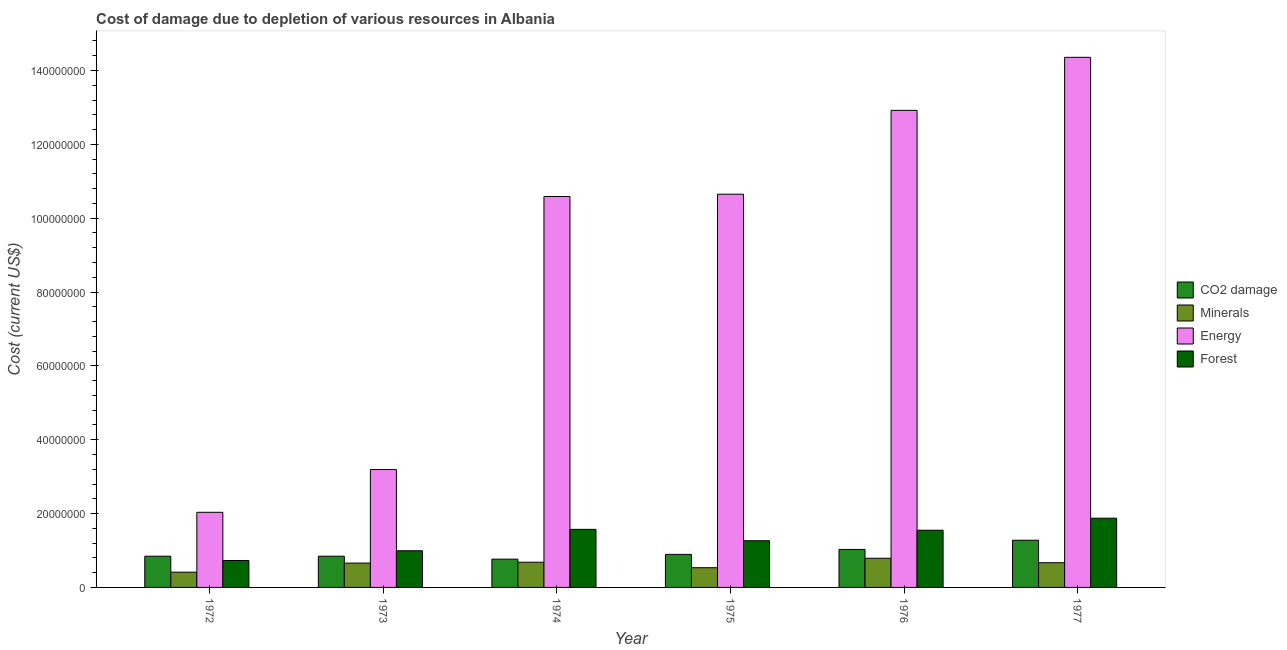How many different coloured bars are there?
Keep it short and to the point. 4. How many groups of bars are there?
Give a very brief answer. 6. Are the number of bars on each tick of the X-axis equal?
Give a very brief answer. Yes. How many bars are there on the 5th tick from the left?
Ensure brevity in your answer.  4. How many bars are there on the 6th tick from the right?
Give a very brief answer. 4. What is the cost of damage due to depletion of forests in 1977?
Offer a terse response. 1.88e+07. Across all years, what is the maximum cost of damage due to depletion of energy?
Offer a very short reply. 1.44e+08. Across all years, what is the minimum cost of damage due to depletion of energy?
Ensure brevity in your answer.  2.03e+07. In which year was the cost of damage due to depletion of minerals maximum?
Provide a short and direct response. 1976. In which year was the cost of damage due to depletion of coal minimum?
Keep it short and to the point. 1974. What is the total cost of damage due to depletion of forests in the graph?
Keep it short and to the point. 7.99e+07. What is the difference between the cost of damage due to depletion of coal in 1972 and that in 1977?
Provide a short and direct response. -4.32e+06. What is the difference between the cost of damage due to depletion of coal in 1974 and the cost of damage due to depletion of energy in 1972?
Your answer should be very brief. -7.97e+05. What is the average cost of damage due to depletion of coal per year?
Make the answer very short. 9.43e+06. In how many years, is the cost of damage due to depletion of coal greater than 24000000 US$?
Your response must be concise. 0. What is the ratio of the cost of damage due to depletion of coal in 1974 to that in 1977?
Your response must be concise. 0.6. Is the difference between the cost of damage due to depletion of minerals in 1973 and 1977 greater than the difference between the cost of damage due to depletion of energy in 1973 and 1977?
Your answer should be very brief. No. What is the difference between the highest and the second highest cost of damage due to depletion of forests?
Offer a very short reply. 3.02e+06. What is the difference between the highest and the lowest cost of damage due to depletion of minerals?
Offer a very short reply. 3.77e+06. Is the sum of the cost of damage due to depletion of minerals in 1974 and 1976 greater than the maximum cost of damage due to depletion of energy across all years?
Make the answer very short. Yes. What does the 4th bar from the left in 1972 represents?
Your response must be concise. Forest. What does the 3rd bar from the right in 1977 represents?
Provide a succinct answer. Minerals. Is it the case that in every year, the sum of the cost of damage due to depletion of coal and cost of damage due to depletion of minerals is greater than the cost of damage due to depletion of energy?
Offer a terse response. No. Are all the bars in the graph horizontal?
Your answer should be compact. No. How many years are there in the graph?
Give a very brief answer. 6. Are the values on the major ticks of Y-axis written in scientific E-notation?
Offer a very short reply. No. Where does the legend appear in the graph?
Keep it short and to the point. Center right. What is the title of the graph?
Give a very brief answer. Cost of damage due to depletion of various resources in Albania . What is the label or title of the Y-axis?
Your answer should be compact. Cost (current US$). What is the Cost (current US$) in CO2 damage in 1972?
Your answer should be compact. 8.45e+06. What is the Cost (current US$) of Minerals in 1972?
Provide a succinct answer. 4.13e+06. What is the Cost (current US$) in Energy in 1972?
Give a very brief answer. 2.03e+07. What is the Cost (current US$) of Forest in 1972?
Make the answer very short. 7.29e+06. What is the Cost (current US$) in CO2 damage in 1973?
Provide a short and direct response. 8.46e+06. What is the Cost (current US$) in Minerals in 1973?
Keep it short and to the point. 6.59e+06. What is the Cost (current US$) of Energy in 1973?
Ensure brevity in your answer.  3.19e+07. What is the Cost (current US$) in Forest in 1973?
Offer a very short reply. 9.93e+06. What is the Cost (current US$) in CO2 damage in 1974?
Provide a short and direct response. 7.66e+06. What is the Cost (current US$) of Minerals in 1974?
Keep it short and to the point. 6.83e+06. What is the Cost (current US$) of Energy in 1974?
Offer a terse response. 1.06e+08. What is the Cost (current US$) of Forest in 1974?
Give a very brief answer. 1.57e+07. What is the Cost (current US$) of CO2 damage in 1975?
Provide a succinct answer. 8.95e+06. What is the Cost (current US$) of Minerals in 1975?
Offer a terse response. 5.34e+06. What is the Cost (current US$) of Energy in 1975?
Provide a short and direct response. 1.06e+08. What is the Cost (current US$) of Forest in 1975?
Offer a terse response. 1.26e+07. What is the Cost (current US$) in CO2 damage in 1976?
Provide a succinct answer. 1.03e+07. What is the Cost (current US$) of Minerals in 1976?
Provide a short and direct response. 7.90e+06. What is the Cost (current US$) in Energy in 1976?
Offer a very short reply. 1.29e+08. What is the Cost (current US$) of Forest in 1976?
Make the answer very short. 1.55e+07. What is the Cost (current US$) of CO2 damage in 1977?
Keep it short and to the point. 1.28e+07. What is the Cost (current US$) in Minerals in 1977?
Your response must be concise. 6.69e+06. What is the Cost (current US$) of Energy in 1977?
Ensure brevity in your answer.  1.44e+08. What is the Cost (current US$) in Forest in 1977?
Keep it short and to the point. 1.88e+07. Across all years, what is the maximum Cost (current US$) of CO2 damage?
Ensure brevity in your answer.  1.28e+07. Across all years, what is the maximum Cost (current US$) in Minerals?
Offer a very short reply. 7.90e+06. Across all years, what is the maximum Cost (current US$) in Energy?
Give a very brief answer. 1.44e+08. Across all years, what is the maximum Cost (current US$) of Forest?
Your answer should be compact. 1.88e+07. Across all years, what is the minimum Cost (current US$) in CO2 damage?
Your answer should be very brief. 7.66e+06. Across all years, what is the minimum Cost (current US$) in Minerals?
Provide a short and direct response. 4.13e+06. Across all years, what is the minimum Cost (current US$) of Energy?
Provide a succinct answer. 2.03e+07. Across all years, what is the minimum Cost (current US$) of Forest?
Offer a terse response. 7.29e+06. What is the total Cost (current US$) of CO2 damage in the graph?
Your answer should be compact. 5.66e+07. What is the total Cost (current US$) in Minerals in the graph?
Provide a succinct answer. 3.75e+07. What is the total Cost (current US$) in Energy in the graph?
Provide a succinct answer. 5.37e+08. What is the total Cost (current US$) of Forest in the graph?
Provide a short and direct response. 7.99e+07. What is the difference between the Cost (current US$) of CO2 damage in 1972 and that in 1973?
Your response must be concise. -2181.69. What is the difference between the Cost (current US$) of Minerals in 1972 and that in 1973?
Offer a very short reply. -2.46e+06. What is the difference between the Cost (current US$) of Energy in 1972 and that in 1973?
Provide a short and direct response. -1.16e+07. What is the difference between the Cost (current US$) of Forest in 1972 and that in 1973?
Offer a very short reply. -2.64e+06. What is the difference between the Cost (current US$) in CO2 damage in 1972 and that in 1974?
Ensure brevity in your answer.  7.97e+05. What is the difference between the Cost (current US$) in Minerals in 1972 and that in 1974?
Offer a very short reply. -2.70e+06. What is the difference between the Cost (current US$) in Energy in 1972 and that in 1974?
Provide a short and direct response. -8.55e+07. What is the difference between the Cost (current US$) in Forest in 1972 and that in 1974?
Give a very brief answer. -8.43e+06. What is the difference between the Cost (current US$) in CO2 damage in 1972 and that in 1975?
Your answer should be very brief. -4.96e+05. What is the difference between the Cost (current US$) in Minerals in 1972 and that in 1975?
Give a very brief answer. -1.21e+06. What is the difference between the Cost (current US$) of Energy in 1972 and that in 1975?
Make the answer very short. -8.61e+07. What is the difference between the Cost (current US$) of Forest in 1972 and that in 1975?
Offer a terse response. -5.35e+06. What is the difference between the Cost (current US$) of CO2 damage in 1972 and that in 1976?
Provide a succinct answer. -1.84e+06. What is the difference between the Cost (current US$) of Minerals in 1972 and that in 1976?
Provide a short and direct response. -3.77e+06. What is the difference between the Cost (current US$) of Energy in 1972 and that in 1976?
Your response must be concise. -1.09e+08. What is the difference between the Cost (current US$) in Forest in 1972 and that in 1976?
Your answer should be compact. -8.20e+06. What is the difference between the Cost (current US$) in CO2 damage in 1972 and that in 1977?
Your answer should be compact. -4.32e+06. What is the difference between the Cost (current US$) in Minerals in 1972 and that in 1977?
Offer a very short reply. -2.56e+06. What is the difference between the Cost (current US$) in Energy in 1972 and that in 1977?
Offer a very short reply. -1.23e+08. What is the difference between the Cost (current US$) of Forest in 1972 and that in 1977?
Give a very brief answer. -1.15e+07. What is the difference between the Cost (current US$) in CO2 damage in 1973 and that in 1974?
Offer a very short reply. 7.99e+05. What is the difference between the Cost (current US$) of Minerals in 1973 and that in 1974?
Offer a very short reply. -2.35e+05. What is the difference between the Cost (current US$) in Energy in 1973 and that in 1974?
Provide a short and direct response. -7.39e+07. What is the difference between the Cost (current US$) in Forest in 1973 and that in 1974?
Give a very brief answer. -5.80e+06. What is the difference between the Cost (current US$) of CO2 damage in 1973 and that in 1975?
Offer a terse response. -4.94e+05. What is the difference between the Cost (current US$) in Minerals in 1973 and that in 1975?
Give a very brief answer. 1.25e+06. What is the difference between the Cost (current US$) of Energy in 1973 and that in 1975?
Provide a short and direct response. -7.46e+07. What is the difference between the Cost (current US$) in Forest in 1973 and that in 1975?
Provide a short and direct response. -2.72e+06. What is the difference between the Cost (current US$) of CO2 damage in 1973 and that in 1976?
Ensure brevity in your answer.  -1.84e+06. What is the difference between the Cost (current US$) of Minerals in 1973 and that in 1976?
Offer a terse response. -1.30e+06. What is the difference between the Cost (current US$) in Energy in 1973 and that in 1976?
Keep it short and to the point. -9.73e+07. What is the difference between the Cost (current US$) of Forest in 1973 and that in 1976?
Ensure brevity in your answer.  -5.56e+06. What is the difference between the Cost (current US$) of CO2 damage in 1973 and that in 1977?
Provide a short and direct response. -4.32e+06. What is the difference between the Cost (current US$) of Minerals in 1973 and that in 1977?
Your answer should be very brief. -1.01e+05. What is the difference between the Cost (current US$) of Energy in 1973 and that in 1977?
Offer a terse response. -1.12e+08. What is the difference between the Cost (current US$) of Forest in 1973 and that in 1977?
Your response must be concise. -8.82e+06. What is the difference between the Cost (current US$) of CO2 damage in 1974 and that in 1975?
Your answer should be very brief. -1.29e+06. What is the difference between the Cost (current US$) of Minerals in 1974 and that in 1975?
Ensure brevity in your answer.  1.49e+06. What is the difference between the Cost (current US$) in Energy in 1974 and that in 1975?
Offer a very short reply. -6.23e+05. What is the difference between the Cost (current US$) in Forest in 1974 and that in 1975?
Provide a succinct answer. 3.08e+06. What is the difference between the Cost (current US$) in CO2 damage in 1974 and that in 1976?
Offer a very short reply. -2.63e+06. What is the difference between the Cost (current US$) of Minerals in 1974 and that in 1976?
Your answer should be very brief. -1.07e+06. What is the difference between the Cost (current US$) in Energy in 1974 and that in 1976?
Make the answer very short. -2.33e+07. What is the difference between the Cost (current US$) of Forest in 1974 and that in 1976?
Provide a succinct answer. 2.37e+05. What is the difference between the Cost (current US$) of CO2 damage in 1974 and that in 1977?
Keep it short and to the point. -5.12e+06. What is the difference between the Cost (current US$) of Minerals in 1974 and that in 1977?
Make the answer very short. 1.34e+05. What is the difference between the Cost (current US$) in Energy in 1974 and that in 1977?
Your response must be concise. -3.77e+07. What is the difference between the Cost (current US$) of Forest in 1974 and that in 1977?
Your response must be concise. -3.02e+06. What is the difference between the Cost (current US$) in CO2 damage in 1975 and that in 1976?
Your answer should be very brief. -1.34e+06. What is the difference between the Cost (current US$) in Minerals in 1975 and that in 1976?
Provide a succinct answer. -2.56e+06. What is the difference between the Cost (current US$) of Energy in 1975 and that in 1976?
Make the answer very short. -2.27e+07. What is the difference between the Cost (current US$) of Forest in 1975 and that in 1976?
Your answer should be very brief. -2.84e+06. What is the difference between the Cost (current US$) of CO2 damage in 1975 and that in 1977?
Give a very brief answer. -3.83e+06. What is the difference between the Cost (current US$) of Minerals in 1975 and that in 1977?
Offer a very short reply. -1.36e+06. What is the difference between the Cost (current US$) of Energy in 1975 and that in 1977?
Your answer should be very brief. -3.71e+07. What is the difference between the Cost (current US$) of Forest in 1975 and that in 1977?
Your response must be concise. -6.10e+06. What is the difference between the Cost (current US$) in CO2 damage in 1976 and that in 1977?
Keep it short and to the point. -2.49e+06. What is the difference between the Cost (current US$) of Minerals in 1976 and that in 1977?
Offer a very short reply. 1.20e+06. What is the difference between the Cost (current US$) of Energy in 1976 and that in 1977?
Offer a very short reply. -1.44e+07. What is the difference between the Cost (current US$) in Forest in 1976 and that in 1977?
Offer a very short reply. -3.26e+06. What is the difference between the Cost (current US$) in CO2 damage in 1972 and the Cost (current US$) in Minerals in 1973?
Provide a succinct answer. 1.86e+06. What is the difference between the Cost (current US$) in CO2 damage in 1972 and the Cost (current US$) in Energy in 1973?
Make the answer very short. -2.35e+07. What is the difference between the Cost (current US$) of CO2 damage in 1972 and the Cost (current US$) of Forest in 1973?
Provide a succinct answer. -1.48e+06. What is the difference between the Cost (current US$) of Minerals in 1972 and the Cost (current US$) of Energy in 1973?
Your response must be concise. -2.78e+07. What is the difference between the Cost (current US$) in Minerals in 1972 and the Cost (current US$) in Forest in 1973?
Offer a very short reply. -5.80e+06. What is the difference between the Cost (current US$) of Energy in 1972 and the Cost (current US$) of Forest in 1973?
Your answer should be very brief. 1.04e+07. What is the difference between the Cost (current US$) of CO2 damage in 1972 and the Cost (current US$) of Minerals in 1974?
Provide a short and direct response. 1.63e+06. What is the difference between the Cost (current US$) of CO2 damage in 1972 and the Cost (current US$) of Energy in 1974?
Your answer should be compact. -9.74e+07. What is the difference between the Cost (current US$) of CO2 damage in 1972 and the Cost (current US$) of Forest in 1974?
Provide a short and direct response. -7.28e+06. What is the difference between the Cost (current US$) of Minerals in 1972 and the Cost (current US$) of Energy in 1974?
Provide a short and direct response. -1.02e+08. What is the difference between the Cost (current US$) in Minerals in 1972 and the Cost (current US$) in Forest in 1974?
Offer a very short reply. -1.16e+07. What is the difference between the Cost (current US$) of Energy in 1972 and the Cost (current US$) of Forest in 1974?
Provide a short and direct response. 4.61e+06. What is the difference between the Cost (current US$) in CO2 damage in 1972 and the Cost (current US$) in Minerals in 1975?
Keep it short and to the point. 3.11e+06. What is the difference between the Cost (current US$) in CO2 damage in 1972 and the Cost (current US$) in Energy in 1975?
Give a very brief answer. -9.80e+07. What is the difference between the Cost (current US$) of CO2 damage in 1972 and the Cost (current US$) of Forest in 1975?
Ensure brevity in your answer.  -4.20e+06. What is the difference between the Cost (current US$) in Minerals in 1972 and the Cost (current US$) in Energy in 1975?
Make the answer very short. -1.02e+08. What is the difference between the Cost (current US$) in Minerals in 1972 and the Cost (current US$) in Forest in 1975?
Offer a terse response. -8.52e+06. What is the difference between the Cost (current US$) of Energy in 1972 and the Cost (current US$) of Forest in 1975?
Provide a short and direct response. 7.70e+06. What is the difference between the Cost (current US$) in CO2 damage in 1972 and the Cost (current US$) in Minerals in 1976?
Keep it short and to the point. 5.56e+05. What is the difference between the Cost (current US$) of CO2 damage in 1972 and the Cost (current US$) of Energy in 1976?
Provide a succinct answer. -1.21e+08. What is the difference between the Cost (current US$) of CO2 damage in 1972 and the Cost (current US$) of Forest in 1976?
Make the answer very short. -7.04e+06. What is the difference between the Cost (current US$) of Minerals in 1972 and the Cost (current US$) of Energy in 1976?
Your answer should be compact. -1.25e+08. What is the difference between the Cost (current US$) of Minerals in 1972 and the Cost (current US$) of Forest in 1976?
Your answer should be compact. -1.14e+07. What is the difference between the Cost (current US$) of Energy in 1972 and the Cost (current US$) of Forest in 1976?
Offer a terse response. 4.85e+06. What is the difference between the Cost (current US$) in CO2 damage in 1972 and the Cost (current US$) in Minerals in 1977?
Give a very brief answer. 1.76e+06. What is the difference between the Cost (current US$) of CO2 damage in 1972 and the Cost (current US$) of Energy in 1977?
Provide a succinct answer. -1.35e+08. What is the difference between the Cost (current US$) in CO2 damage in 1972 and the Cost (current US$) in Forest in 1977?
Offer a very short reply. -1.03e+07. What is the difference between the Cost (current US$) of Minerals in 1972 and the Cost (current US$) of Energy in 1977?
Provide a succinct answer. -1.39e+08. What is the difference between the Cost (current US$) of Minerals in 1972 and the Cost (current US$) of Forest in 1977?
Give a very brief answer. -1.46e+07. What is the difference between the Cost (current US$) of Energy in 1972 and the Cost (current US$) of Forest in 1977?
Give a very brief answer. 1.59e+06. What is the difference between the Cost (current US$) in CO2 damage in 1973 and the Cost (current US$) in Minerals in 1974?
Your answer should be compact. 1.63e+06. What is the difference between the Cost (current US$) of CO2 damage in 1973 and the Cost (current US$) of Energy in 1974?
Provide a short and direct response. -9.74e+07. What is the difference between the Cost (current US$) of CO2 damage in 1973 and the Cost (current US$) of Forest in 1974?
Offer a very short reply. -7.27e+06. What is the difference between the Cost (current US$) in Minerals in 1973 and the Cost (current US$) in Energy in 1974?
Provide a succinct answer. -9.93e+07. What is the difference between the Cost (current US$) in Minerals in 1973 and the Cost (current US$) in Forest in 1974?
Provide a short and direct response. -9.14e+06. What is the difference between the Cost (current US$) of Energy in 1973 and the Cost (current US$) of Forest in 1974?
Offer a terse response. 1.62e+07. What is the difference between the Cost (current US$) in CO2 damage in 1973 and the Cost (current US$) in Minerals in 1975?
Give a very brief answer. 3.12e+06. What is the difference between the Cost (current US$) in CO2 damage in 1973 and the Cost (current US$) in Energy in 1975?
Your answer should be very brief. -9.80e+07. What is the difference between the Cost (current US$) of CO2 damage in 1973 and the Cost (current US$) of Forest in 1975?
Your response must be concise. -4.19e+06. What is the difference between the Cost (current US$) in Minerals in 1973 and the Cost (current US$) in Energy in 1975?
Your answer should be compact. -9.99e+07. What is the difference between the Cost (current US$) in Minerals in 1973 and the Cost (current US$) in Forest in 1975?
Ensure brevity in your answer.  -6.06e+06. What is the difference between the Cost (current US$) of Energy in 1973 and the Cost (current US$) of Forest in 1975?
Give a very brief answer. 1.93e+07. What is the difference between the Cost (current US$) in CO2 damage in 1973 and the Cost (current US$) in Minerals in 1976?
Provide a succinct answer. 5.58e+05. What is the difference between the Cost (current US$) of CO2 damage in 1973 and the Cost (current US$) of Energy in 1976?
Keep it short and to the point. -1.21e+08. What is the difference between the Cost (current US$) in CO2 damage in 1973 and the Cost (current US$) in Forest in 1976?
Keep it short and to the point. -7.04e+06. What is the difference between the Cost (current US$) in Minerals in 1973 and the Cost (current US$) in Energy in 1976?
Offer a terse response. -1.23e+08. What is the difference between the Cost (current US$) in Minerals in 1973 and the Cost (current US$) in Forest in 1976?
Your response must be concise. -8.90e+06. What is the difference between the Cost (current US$) in Energy in 1973 and the Cost (current US$) in Forest in 1976?
Provide a short and direct response. 1.64e+07. What is the difference between the Cost (current US$) in CO2 damage in 1973 and the Cost (current US$) in Minerals in 1977?
Your answer should be very brief. 1.76e+06. What is the difference between the Cost (current US$) in CO2 damage in 1973 and the Cost (current US$) in Energy in 1977?
Keep it short and to the point. -1.35e+08. What is the difference between the Cost (current US$) of CO2 damage in 1973 and the Cost (current US$) of Forest in 1977?
Give a very brief answer. -1.03e+07. What is the difference between the Cost (current US$) of Minerals in 1973 and the Cost (current US$) of Energy in 1977?
Provide a succinct answer. -1.37e+08. What is the difference between the Cost (current US$) of Minerals in 1973 and the Cost (current US$) of Forest in 1977?
Offer a very short reply. -1.22e+07. What is the difference between the Cost (current US$) in Energy in 1973 and the Cost (current US$) in Forest in 1977?
Offer a very short reply. 1.32e+07. What is the difference between the Cost (current US$) of CO2 damage in 1974 and the Cost (current US$) of Minerals in 1975?
Offer a terse response. 2.32e+06. What is the difference between the Cost (current US$) of CO2 damage in 1974 and the Cost (current US$) of Energy in 1975?
Give a very brief answer. -9.88e+07. What is the difference between the Cost (current US$) of CO2 damage in 1974 and the Cost (current US$) of Forest in 1975?
Make the answer very short. -4.99e+06. What is the difference between the Cost (current US$) of Minerals in 1974 and the Cost (current US$) of Energy in 1975?
Give a very brief answer. -9.97e+07. What is the difference between the Cost (current US$) in Minerals in 1974 and the Cost (current US$) in Forest in 1975?
Keep it short and to the point. -5.82e+06. What is the difference between the Cost (current US$) of Energy in 1974 and the Cost (current US$) of Forest in 1975?
Give a very brief answer. 9.32e+07. What is the difference between the Cost (current US$) of CO2 damage in 1974 and the Cost (current US$) of Minerals in 1976?
Make the answer very short. -2.41e+05. What is the difference between the Cost (current US$) of CO2 damage in 1974 and the Cost (current US$) of Energy in 1976?
Provide a short and direct response. -1.22e+08. What is the difference between the Cost (current US$) of CO2 damage in 1974 and the Cost (current US$) of Forest in 1976?
Give a very brief answer. -7.84e+06. What is the difference between the Cost (current US$) of Minerals in 1974 and the Cost (current US$) of Energy in 1976?
Make the answer very short. -1.22e+08. What is the difference between the Cost (current US$) in Minerals in 1974 and the Cost (current US$) in Forest in 1976?
Your answer should be very brief. -8.66e+06. What is the difference between the Cost (current US$) of Energy in 1974 and the Cost (current US$) of Forest in 1976?
Your answer should be very brief. 9.04e+07. What is the difference between the Cost (current US$) in CO2 damage in 1974 and the Cost (current US$) in Minerals in 1977?
Your answer should be very brief. 9.62e+05. What is the difference between the Cost (current US$) of CO2 damage in 1974 and the Cost (current US$) of Energy in 1977?
Provide a succinct answer. -1.36e+08. What is the difference between the Cost (current US$) in CO2 damage in 1974 and the Cost (current US$) in Forest in 1977?
Your response must be concise. -1.11e+07. What is the difference between the Cost (current US$) in Minerals in 1974 and the Cost (current US$) in Energy in 1977?
Provide a succinct answer. -1.37e+08. What is the difference between the Cost (current US$) in Minerals in 1974 and the Cost (current US$) in Forest in 1977?
Your answer should be compact. -1.19e+07. What is the difference between the Cost (current US$) of Energy in 1974 and the Cost (current US$) of Forest in 1977?
Provide a short and direct response. 8.71e+07. What is the difference between the Cost (current US$) of CO2 damage in 1975 and the Cost (current US$) of Minerals in 1976?
Keep it short and to the point. 1.05e+06. What is the difference between the Cost (current US$) in CO2 damage in 1975 and the Cost (current US$) in Energy in 1976?
Keep it short and to the point. -1.20e+08. What is the difference between the Cost (current US$) in CO2 damage in 1975 and the Cost (current US$) in Forest in 1976?
Give a very brief answer. -6.54e+06. What is the difference between the Cost (current US$) in Minerals in 1975 and the Cost (current US$) in Energy in 1976?
Your response must be concise. -1.24e+08. What is the difference between the Cost (current US$) of Minerals in 1975 and the Cost (current US$) of Forest in 1976?
Provide a short and direct response. -1.02e+07. What is the difference between the Cost (current US$) of Energy in 1975 and the Cost (current US$) of Forest in 1976?
Ensure brevity in your answer.  9.10e+07. What is the difference between the Cost (current US$) in CO2 damage in 1975 and the Cost (current US$) in Minerals in 1977?
Provide a short and direct response. 2.25e+06. What is the difference between the Cost (current US$) of CO2 damage in 1975 and the Cost (current US$) of Energy in 1977?
Keep it short and to the point. -1.35e+08. What is the difference between the Cost (current US$) in CO2 damage in 1975 and the Cost (current US$) in Forest in 1977?
Your answer should be very brief. -9.80e+06. What is the difference between the Cost (current US$) of Minerals in 1975 and the Cost (current US$) of Energy in 1977?
Offer a very short reply. -1.38e+08. What is the difference between the Cost (current US$) in Minerals in 1975 and the Cost (current US$) in Forest in 1977?
Provide a succinct answer. -1.34e+07. What is the difference between the Cost (current US$) in Energy in 1975 and the Cost (current US$) in Forest in 1977?
Provide a succinct answer. 8.77e+07. What is the difference between the Cost (current US$) of CO2 damage in 1976 and the Cost (current US$) of Minerals in 1977?
Your answer should be very brief. 3.60e+06. What is the difference between the Cost (current US$) in CO2 damage in 1976 and the Cost (current US$) in Energy in 1977?
Your response must be concise. -1.33e+08. What is the difference between the Cost (current US$) of CO2 damage in 1976 and the Cost (current US$) of Forest in 1977?
Give a very brief answer. -8.46e+06. What is the difference between the Cost (current US$) of Minerals in 1976 and the Cost (current US$) of Energy in 1977?
Ensure brevity in your answer.  -1.36e+08. What is the difference between the Cost (current US$) of Minerals in 1976 and the Cost (current US$) of Forest in 1977?
Keep it short and to the point. -1.09e+07. What is the difference between the Cost (current US$) of Energy in 1976 and the Cost (current US$) of Forest in 1977?
Your response must be concise. 1.10e+08. What is the average Cost (current US$) of CO2 damage per year?
Offer a very short reply. 9.43e+06. What is the average Cost (current US$) in Minerals per year?
Provide a short and direct response. 6.25e+06. What is the average Cost (current US$) of Energy per year?
Offer a very short reply. 8.96e+07. What is the average Cost (current US$) of Forest per year?
Your answer should be very brief. 1.33e+07. In the year 1972, what is the difference between the Cost (current US$) in CO2 damage and Cost (current US$) in Minerals?
Make the answer very short. 4.32e+06. In the year 1972, what is the difference between the Cost (current US$) in CO2 damage and Cost (current US$) in Energy?
Your answer should be compact. -1.19e+07. In the year 1972, what is the difference between the Cost (current US$) of CO2 damage and Cost (current US$) of Forest?
Make the answer very short. 1.16e+06. In the year 1972, what is the difference between the Cost (current US$) of Minerals and Cost (current US$) of Energy?
Offer a very short reply. -1.62e+07. In the year 1972, what is the difference between the Cost (current US$) in Minerals and Cost (current US$) in Forest?
Provide a succinct answer. -3.16e+06. In the year 1972, what is the difference between the Cost (current US$) of Energy and Cost (current US$) of Forest?
Make the answer very short. 1.30e+07. In the year 1973, what is the difference between the Cost (current US$) in CO2 damage and Cost (current US$) in Minerals?
Your answer should be very brief. 1.86e+06. In the year 1973, what is the difference between the Cost (current US$) in CO2 damage and Cost (current US$) in Energy?
Make the answer very short. -2.35e+07. In the year 1973, what is the difference between the Cost (current US$) of CO2 damage and Cost (current US$) of Forest?
Your answer should be compact. -1.48e+06. In the year 1973, what is the difference between the Cost (current US$) in Minerals and Cost (current US$) in Energy?
Give a very brief answer. -2.53e+07. In the year 1973, what is the difference between the Cost (current US$) in Minerals and Cost (current US$) in Forest?
Your answer should be compact. -3.34e+06. In the year 1973, what is the difference between the Cost (current US$) of Energy and Cost (current US$) of Forest?
Give a very brief answer. 2.20e+07. In the year 1974, what is the difference between the Cost (current US$) of CO2 damage and Cost (current US$) of Minerals?
Your answer should be compact. 8.28e+05. In the year 1974, what is the difference between the Cost (current US$) in CO2 damage and Cost (current US$) in Energy?
Make the answer very short. -9.82e+07. In the year 1974, what is the difference between the Cost (current US$) of CO2 damage and Cost (current US$) of Forest?
Your answer should be very brief. -8.07e+06. In the year 1974, what is the difference between the Cost (current US$) in Minerals and Cost (current US$) in Energy?
Offer a terse response. -9.90e+07. In the year 1974, what is the difference between the Cost (current US$) of Minerals and Cost (current US$) of Forest?
Your answer should be very brief. -8.90e+06. In the year 1974, what is the difference between the Cost (current US$) of Energy and Cost (current US$) of Forest?
Your answer should be compact. 9.01e+07. In the year 1975, what is the difference between the Cost (current US$) in CO2 damage and Cost (current US$) in Minerals?
Your answer should be compact. 3.61e+06. In the year 1975, what is the difference between the Cost (current US$) of CO2 damage and Cost (current US$) of Energy?
Your answer should be very brief. -9.75e+07. In the year 1975, what is the difference between the Cost (current US$) of CO2 damage and Cost (current US$) of Forest?
Make the answer very short. -3.70e+06. In the year 1975, what is the difference between the Cost (current US$) of Minerals and Cost (current US$) of Energy?
Give a very brief answer. -1.01e+08. In the year 1975, what is the difference between the Cost (current US$) in Minerals and Cost (current US$) in Forest?
Offer a terse response. -7.31e+06. In the year 1975, what is the difference between the Cost (current US$) in Energy and Cost (current US$) in Forest?
Your response must be concise. 9.38e+07. In the year 1976, what is the difference between the Cost (current US$) in CO2 damage and Cost (current US$) in Minerals?
Keep it short and to the point. 2.39e+06. In the year 1976, what is the difference between the Cost (current US$) of CO2 damage and Cost (current US$) of Energy?
Your answer should be compact. -1.19e+08. In the year 1976, what is the difference between the Cost (current US$) in CO2 damage and Cost (current US$) in Forest?
Keep it short and to the point. -5.20e+06. In the year 1976, what is the difference between the Cost (current US$) in Minerals and Cost (current US$) in Energy?
Provide a succinct answer. -1.21e+08. In the year 1976, what is the difference between the Cost (current US$) of Minerals and Cost (current US$) of Forest?
Your response must be concise. -7.60e+06. In the year 1976, what is the difference between the Cost (current US$) in Energy and Cost (current US$) in Forest?
Keep it short and to the point. 1.14e+08. In the year 1977, what is the difference between the Cost (current US$) in CO2 damage and Cost (current US$) in Minerals?
Offer a terse response. 6.08e+06. In the year 1977, what is the difference between the Cost (current US$) of CO2 damage and Cost (current US$) of Energy?
Provide a short and direct response. -1.31e+08. In the year 1977, what is the difference between the Cost (current US$) of CO2 damage and Cost (current US$) of Forest?
Your answer should be compact. -5.97e+06. In the year 1977, what is the difference between the Cost (current US$) in Minerals and Cost (current US$) in Energy?
Your response must be concise. -1.37e+08. In the year 1977, what is the difference between the Cost (current US$) of Minerals and Cost (current US$) of Forest?
Ensure brevity in your answer.  -1.21e+07. In the year 1977, what is the difference between the Cost (current US$) of Energy and Cost (current US$) of Forest?
Provide a short and direct response. 1.25e+08. What is the ratio of the Cost (current US$) in Minerals in 1972 to that in 1973?
Ensure brevity in your answer.  0.63. What is the ratio of the Cost (current US$) in Energy in 1972 to that in 1973?
Provide a short and direct response. 0.64. What is the ratio of the Cost (current US$) of Forest in 1972 to that in 1973?
Keep it short and to the point. 0.73. What is the ratio of the Cost (current US$) in CO2 damage in 1972 to that in 1974?
Offer a very short reply. 1.1. What is the ratio of the Cost (current US$) in Minerals in 1972 to that in 1974?
Your answer should be very brief. 0.61. What is the ratio of the Cost (current US$) of Energy in 1972 to that in 1974?
Offer a very short reply. 0.19. What is the ratio of the Cost (current US$) in Forest in 1972 to that in 1974?
Your response must be concise. 0.46. What is the ratio of the Cost (current US$) in CO2 damage in 1972 to that in 1975?
Your answer should be very brief. 0.94. What is the ratio of the Cost (current US$) in Minerals in 1972 to that in 1975?
Your response must be concise. 0.77. What is the ratio of the Cost (current US$) of Energy in 1972 to that in 1975?
Make the answer very short. 0.19. What is the ratio of the Cost (current US$) of Forest in 1972 to that in 1975?
Provide a succinct answer. 0.58. What is the ratio of the Cost (current US$) in CO2 damage in 1972 to that in 1976?
Keep it short and to the point. 0.82. What is the ratio of the Cost (current US$) in Minerals in 1972 to that in 1976?
Keep it short and to the point. 0.52. What is the ratio of the Cost (current US$) in Energy in 1972 to that in 1976?
Keep it short and to the point. 0.16. What is the ratio of the Cost (current US$) in Forest in 1972 to that in 1976?
Provide a short and direct response. 0.47. What is the ratio of the Cost (current US$) in CO2 damage in 1972 to that in 1977?
Give a very brief answer. 0.66. What is the ratio of the Cost (current US$) in Minerals in 1972 to that in 1977?
Provide a short and direct response. 0.62. What is the ratio of the Cost (current US$) in Energy in 1972 to that in 1977?
Provide a short and direct response. 0.14. What is the ratio of the Cost (current US$) in Forest in 1972 to that in 1977?
Keep it short and to the point. 0.39. What is the ratio of the Cost (current US$) of CO2 damage in 1973 to that in 1974?
Provide a succinct answer. 1.1. What is the ratio of the Cost (current US$) in Minerals in 1973 to that in 1974?
Your response must be concise. 0.97. What is the ratio of the Cost (current US$) of Energy in 1973 to that in 1974?
Provide a succinct answer. 0.3. What is the ratio of the Cost (current US$) of Forest in 1973 to that in 1974?
Keep it short and to the point. 0.63. What is the ratio of the Cost (current US$) in CO2 damage in 1973 to that in 1975?
Make the answer very short. 0.94. What is the ratio of the Cost (current US$) in Minerals in 1973 to that in 1975?
Make the answer very short. 1.23. What is the ratio of the Cost (current US$) of Energy in 1973 to that in 1975?
Give a very brief answer. 0.3. What is the ratio of the Cost (current US$) in Forest in 1973 to that in 1975?
Ensure brevity in your answer.  0.79. What is the ratio of the Cost (current US$) of CO2 damage in 1973 to that in 1976?
Provide a short and direct response. 0.82. What is the ratio of the Cost (current US$) in Minerals in 1973 to that in 1976?
Provide a succinct answer. 0.83. What is the ratio of the Cost (current US$) in Energy in 1973 to that in 1976?
Your response must be concise. 0.25. What is the ratio of the Cost (current US$) in Forest in 1973 to that in 1976?
Your answer should be very brief. 0.64. What is the ratio of the Cost (current US$) of CO2 damage in 1973 to that in 1977?
Make the answer very short. 0.66. What is the ratio of the Cost (current US$) of Minerals in 1973 to that in 1977?
Your answer should be compact. 0.98. What is the ratio of the Cost (current US$) in Energy in 1973 to that in 1977?
Offer a very short reply. 0.22. What is the ratio of the Cost (current US$) of Forest in 1973 to that in 1977?
Provide a short and direct response. 0.53. What is the ratio of the Cost (current US$) of CO2 damage in 1974 to that in 1975?
Offer a terse response. 0.86. What is the ratio of the Cost (current US$) of Minerals in 1974 to that in 1975?
Your answer should be compact. 1.28. What is the ratio of the Cost (current US$) in Forest in 1974 to that in 1975?
Your response must be concise. 1.24. What is the ratio of the Cost (current US$) of CO2 damage in 1974 to that in 1976?
Provide a short and direct response. 0.74. What is the ratio of the Cost (current US$) in Minerals in 1974 to that in 1976?
Offer a terse response. 0.86. What is the ratio of the Cost (current US$) in Energy in 1974 to that in 1976?
Ensure brevity in your answer.  0.82. What is the ratio of the Cost (current US$) of Forest in 1974 to that in 1976?
Give a very brief answer. 1.02. What is the ratio of the Cost (current US$) in CO2 damage in 1974 to that in 1977?
Give a very brief answer. 0.6. What is the ratio of the Cost (current US$) in Minerals in 1974 to that in 1977?
Offer a terse response. 1.02. What is the ratio of the Cost (current US$) in Energy in 1974 to that in 1977?
Offer a very short reply. 0.74. What is the ratio of the Cost (current US$) of Forest in 1974 to that in 1977?
Keep it short and to the point. 0.84. What is the ratio of the Cost (current US$) of CO2 damage in 1975 to that in 1976?
Ensure brevity in your answer.  0.87. What is the ratio of the Cost (current US$) in Minerals in 1975 to that in 1976?
Your answer should be very brief. 0.68. What is the ratio of the Cost (current US$) in Energy in 1975 to that in 1976?
Provide a succinct answer. 0.82. What is the ratio of the Cost (current US$) of Forest in 1975 to that in 1976?
Offer a terse response. 0.82. What is the ratio of the Cost (current US$) in CO2 damage in 1975 to that in 1977?
Ensure brevity in your answer.  0.7. What is the ratio of the Cost (current US$) of Minerals in 1975 to that in 1977?
Offer a terse response. 0.8. What is the ratio of the Cost (current US$) of Energy in 1975 to that in 1977?
Your response must be concise. 0.74. What is the ratio of the Cost (current US$) in Forest in 1975 to that in 1977?
Your answer should be compact. 0.67. What is the ratio of the Cost (current US$) in CO2 damage in 1976 to that in 1977?
Your answer should be compact. 0.81. What is the ratio of the Cost (current US$) in Minerals in 1976 to that in 1977?
Ensure brevity in your answer.  1.18. What is the ratio of the Cost (current US$) of Forest in 1976 to that in 1977?
Your answer should be compact. 0.83. What is the difference between the highest and the second highest Cost (current US$) of CO2 damage?
Keep it short and to the point. 2.49e+06. What is the difference between the highest and the second highest Cost (current US$) of Minerals?
Provide a succinct answer. 1.07e+06. What is the difference between the highest and the second highest Cost (current US$) of Energy?
Offer a terse response. 1.44e+07. What is the difference between the highest and the second highest Cost (current US$) in Forest?
Give a very brief answer. 3.02e+06. What is the difference between the highest and the lowest Cost (current US$) of CO2 damage?
Your answer should be compact. 5.12e+06. What is the difference between the highest and the lowest Cost (current US$) in Minerals?
Your response must be concise. 3.77e+06. What is the difference between the highest and the lowest Cost (current US$) in Energy?
Ensure brevity in your answer.  1.23e+08. What is the difference between the highest and the lowest Cost (current US$) in Forest?
Your answer should be very brief. 1.15e+07. 